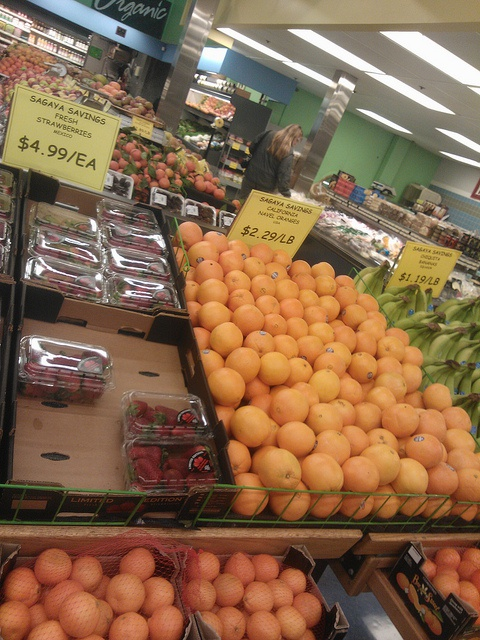Describe the objects in this image and their specific colors. I can see orange in black, orange, brown, and red tones, people in black and gray tones, banana in black and olive tones, banana in black and olive tones, and banana in black and olive tones in this image. 